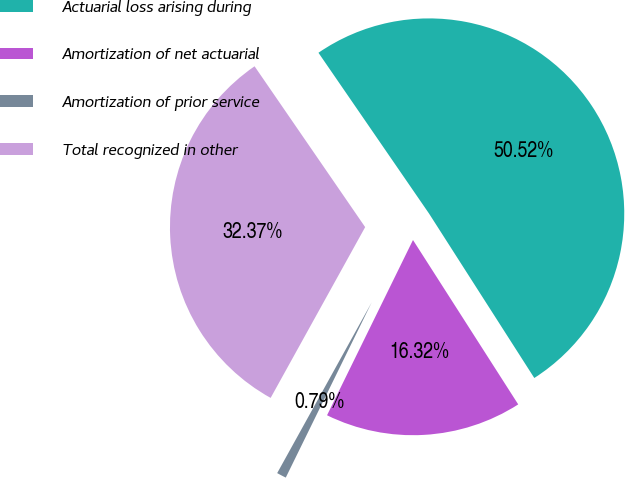Convert chart to OTSL. <chart><loc_0><loc_0><loc_500><loc_500><pie_chart><fcel>Actuarial loss arising during<fcel>Amortization of net actuarial<fcel>Amortization of prior service<fcel>Total recognized in other<nl><fcel>50.53%<fcel>16.32%<fcel>0.79%<fcel>32.37%<nl></chart> 